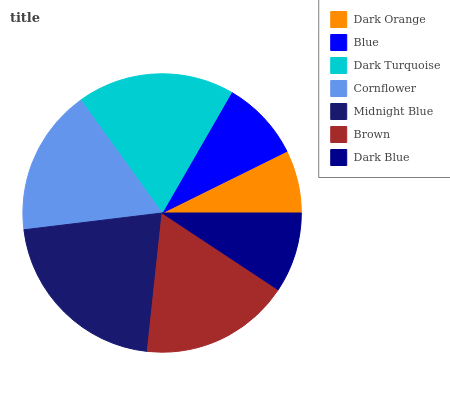Is Dark Orange the minimum?
Answer yes or no. Yes. Is Midnight Blue the maximum?
Answer yes or no. Yes. Is Blue the minimum?
Answer yes or no. No. Is Blue the maximum?
Answer yes or no. No. Is Blue greater than Dark Orange?
Answer yes or no. Yes. Is Dark Orange less than Blue?
Answer yes or no. Yes. Is Dark Orange greater than Blue?
Answer yes or no. No. Is Blue less than Dark Orange?
Answer yes or no. No. Is Cornflower the high median?
Answer yes or no. Yes. Is Cornflower the low median?
Answer yes or no. Yes. Is Brown the high median?
Answer yes or no. No. Is Dark Blue the low median?
Answer yes or no. No. 